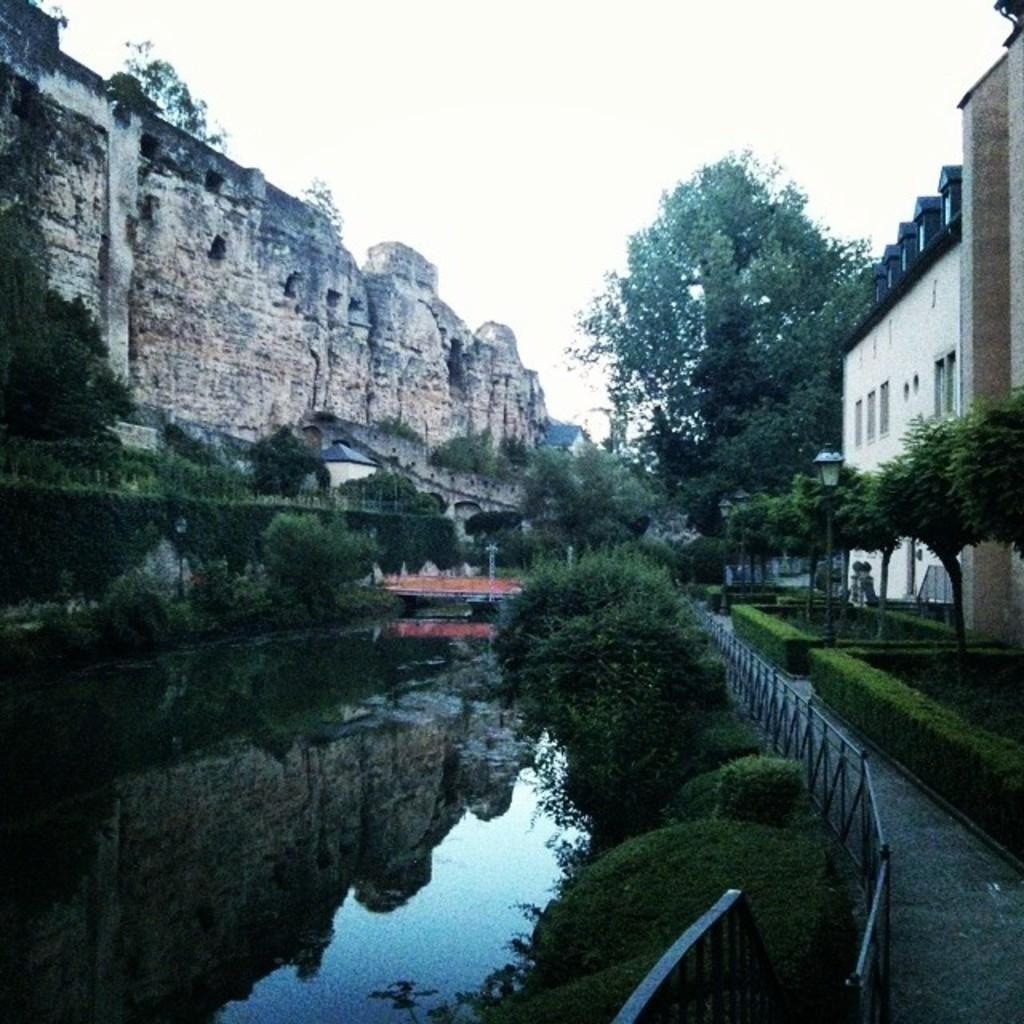Describe this image in one or two sentences. There is water. On the sides of the water there are bushes and railings. Also there are trees and buildings with windows. In the background there is sky. On the left side there is a brick wall. 